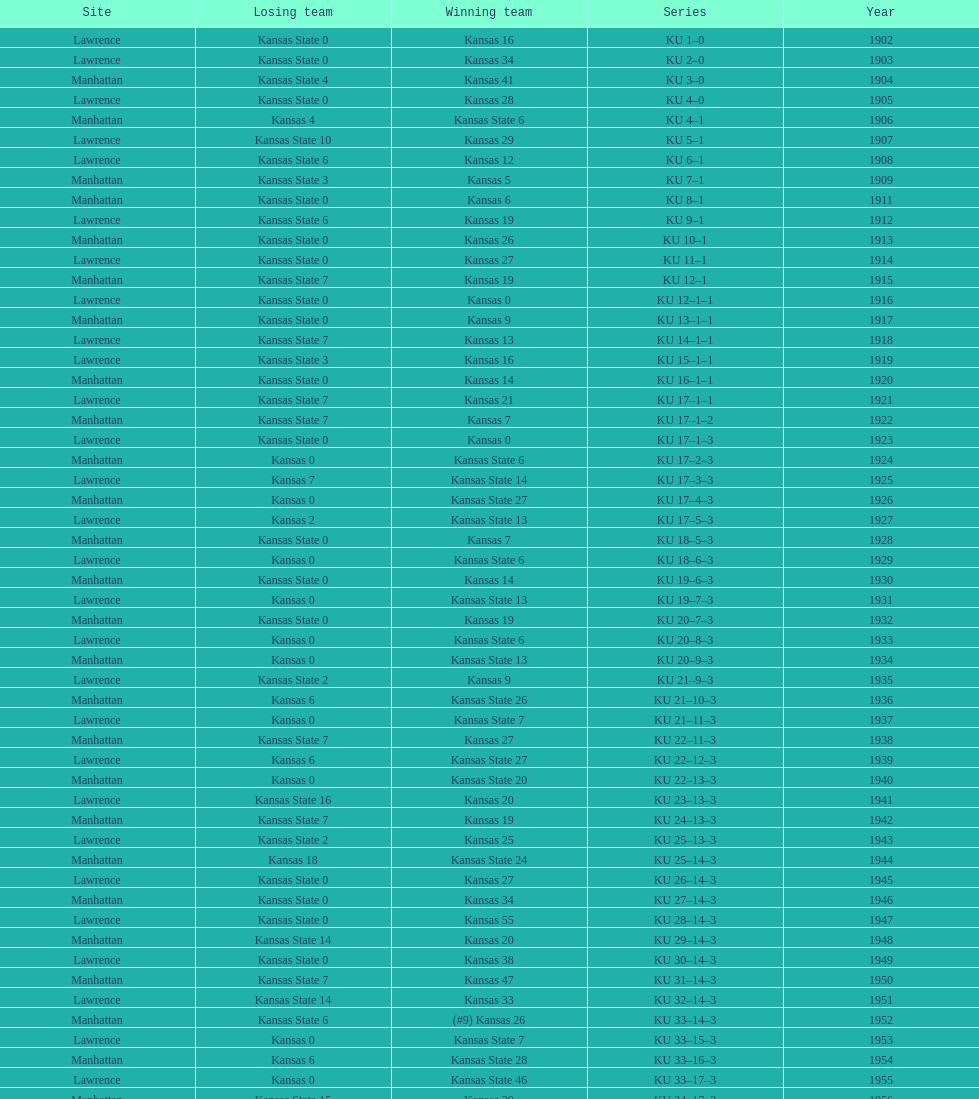What is the total number of games played? 66. 